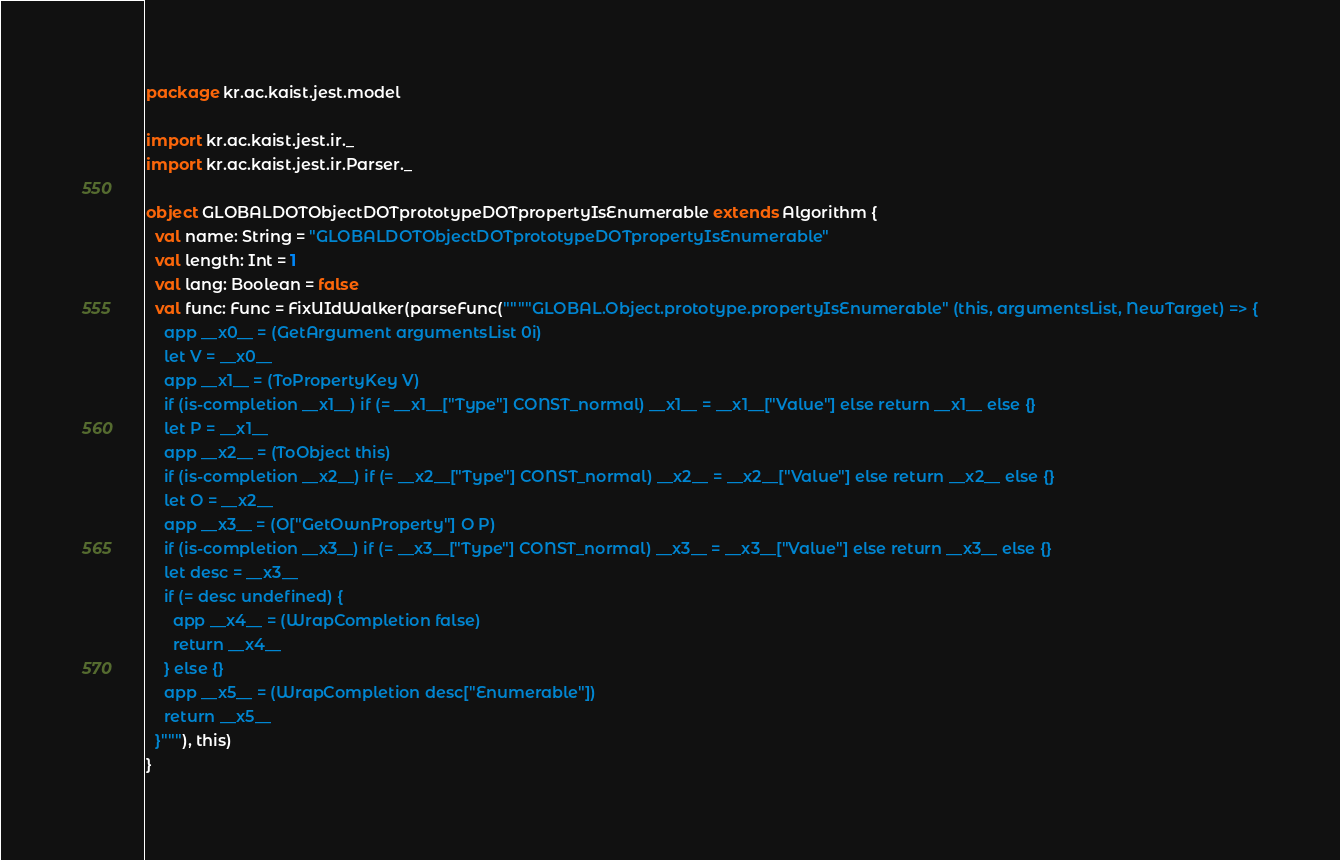<code> <loc_0><loc_0><loc_500><loc_500><_Scala_>package kr.ac.kaist.jest.model

import kr.ac.kaist.jest.ir._
import kr.ac.kaist.jest.ir.Parser._

object GLOBALDOTObjectDOTprototypeDOTpropertyIsEnumerable extends Algorithm {
  val name: String = "GLOBALDOTObjectDOTprototypeDOTpropertyIsEnumerable"
  val length: Int = 1
  val lang: Boolean = false
  val func: Func = FixUIdWalker(parseFunc(""""GLOBAL.Object.prototype.propertyIsEnumerable" (this, argumentsList, NewTarget) => {
    app __x0__ = (GetArgument argumentsList 0i)
    let V = __x0__
    app __x1__ = (ToPropertyKey V)
    if (is-completion __x1__) if (= __x1__["Type"] CONST_normal) __x1__ = __x1__["Value"] else return __x1__ else {}
    let P = __x1__
    app __x2__ = (ToObject this)
    if (is-completion __x2__) if (= __x2__["Type"] CONST_normal) __x2__ = __x2__["Value"] else return __x2__ else {}
    let O = __x2__
    app __x3__ = (O["GetOwnProperty"] O P)
    if (is-completion __x3__) if (= __x3__["Type"] CONST_normal) __x3__ = __x3__["Value"] else return __x3__ else {}
    let desc = __x3__
    if (= desc undefined) {
      app __x4__ = (WrapCompletion false)
      return __x4__
    } else {}
    app __x5__ = (WrapCompletion desc["Enumerable"])
    return __x5__
  }"""), this)
}
</code> 